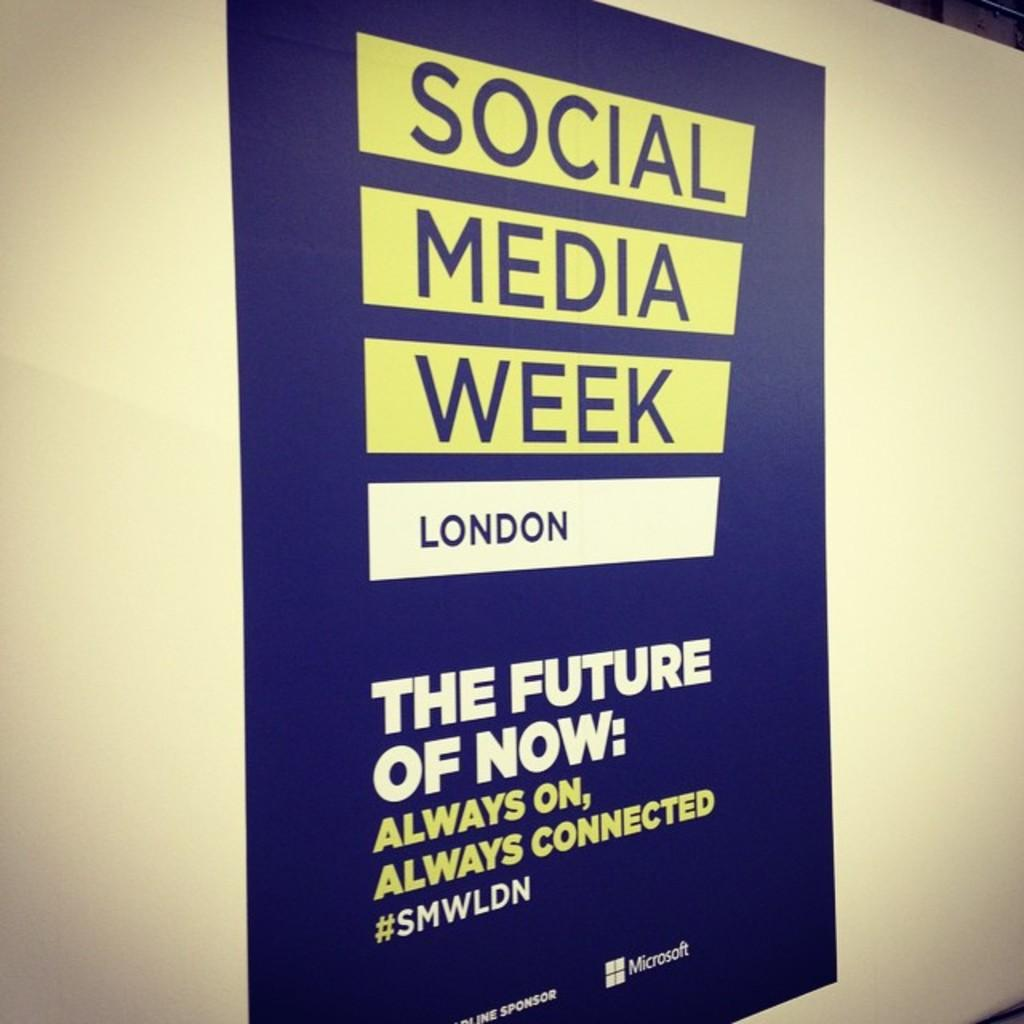Provide a one-sentence caption for the provided image. A poster declares that it's Social Media Week in London and the subject is THE FUTURE OF NOW. 